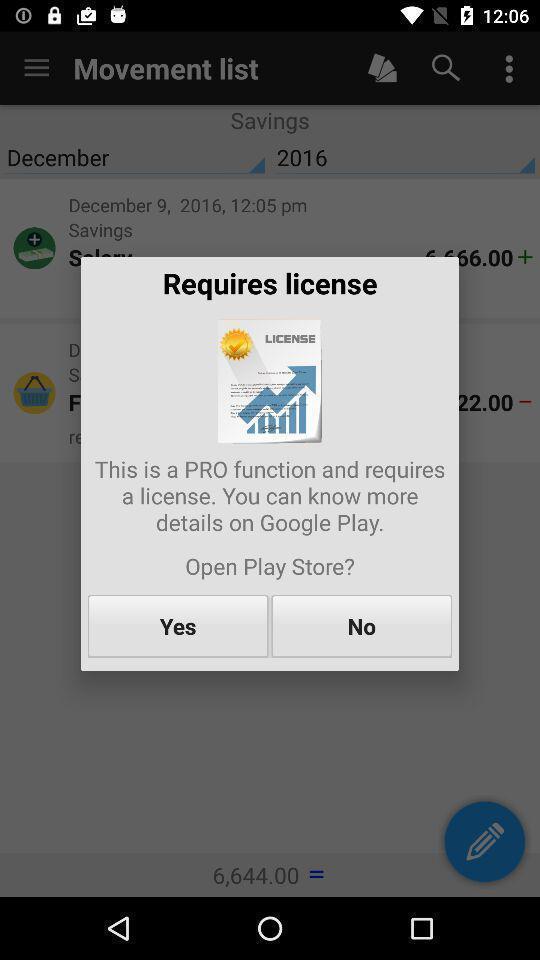What is the overall content of this screenshot? Popup asking licence is required. 